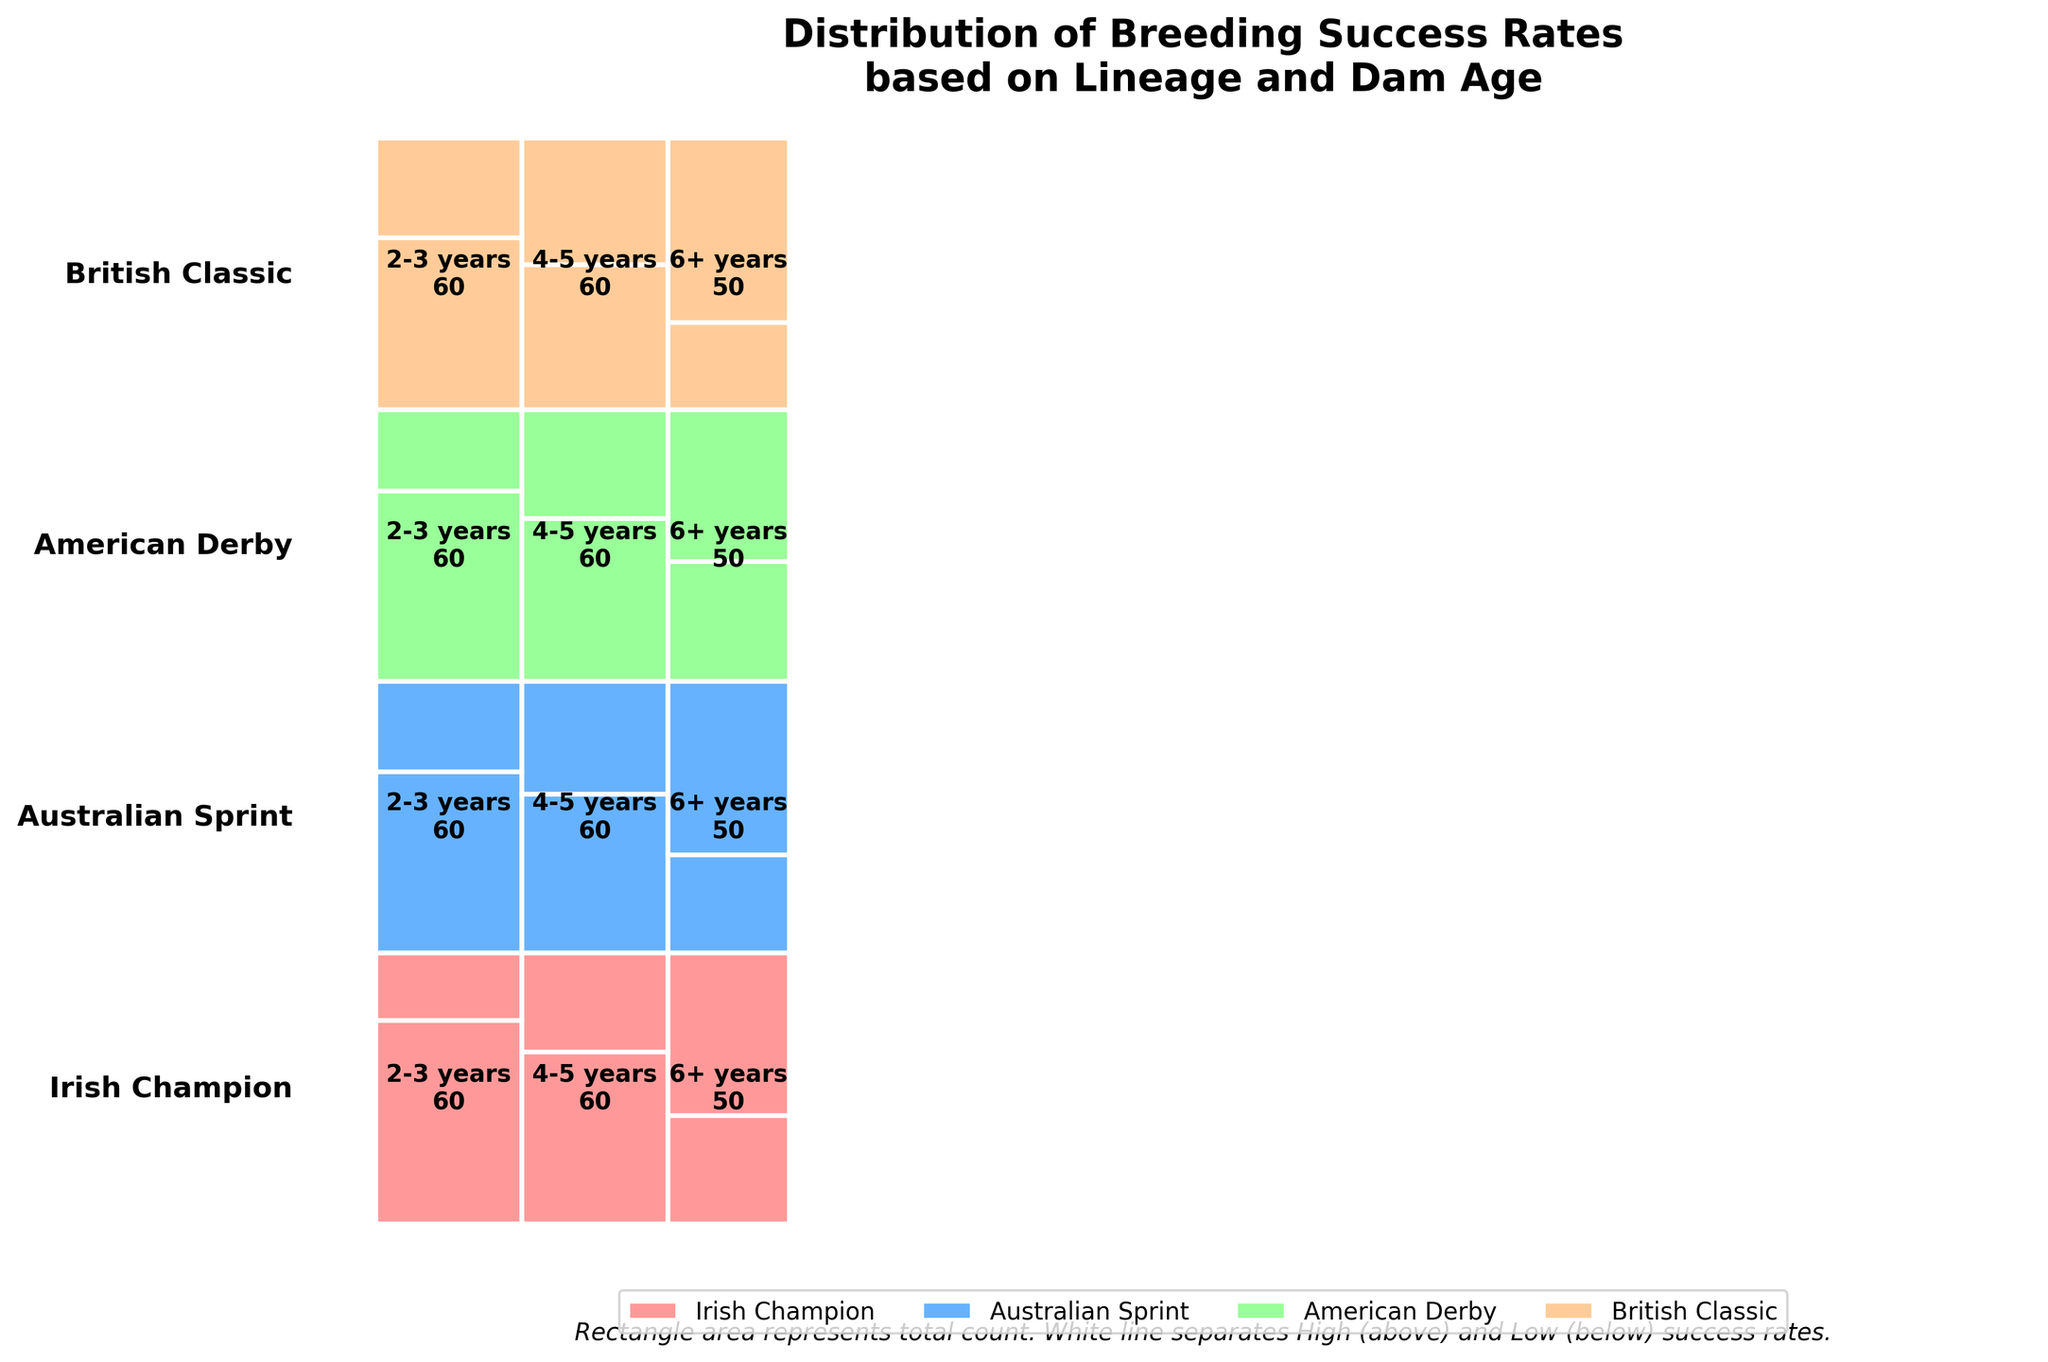Which lineage has the highest total breeding success rate for dams aged 2-3 years? Look at the height of the segments labeled "2-3 years" and how much of it is taken up by the high success section (above the white line). The sum of the count for the high success rate within each lineage can be compared visually. The Irish Champion has a large high-success segment for 2-3 years.
Answer: Irish Champion Which dam age group in the British Classic lineage had the lowest high breeding success rate? Check which segment in the British Classic lineage has the smallest high-success section (portion above the white line). The "6+ years" dam age group has the smallest high-success section.
Answer: 6+ years How does the high breeding success rate for American Derby dams aged 4-5 years compare to that of Australian Sprint dams aged 6+ years? The height of the high success rate in the "4-5 years" section of American Derby lineage is larger than the high success section for the "6+ years" section of the Australian Sprint lineage. This comparison shows a higher breed success in the American Derby 4-5 years group.
Answer: American Derby 4-5 years is higher Which lineage shows a tendency toward higher low breeding success in older dams? Observe the segments of the lineages with older dam ages ("6+ years") and see which one has a larger area dedicated to low success (below the white line). The British Classic shows a tendency for higher low breeding success in older dams.
Answer: British Classic What is the largest overall dam age group observed in the plot? Sum up the width of the segments for each age group across all lineages. The group with the widest total segment indicates the largest dam age group. The "2-3 years" group takes up the most space across the plot.
Answer: 2-3 years Which lineage has the least variance in breeding success rates across all dam ages? Check each lineage and visually assess which one has the most balanced heights between high and low success across all ages. The Australian Sprint seems to have a more balanced high-low success ratio across all dam ages.
Answer: Australian Sprint What is the ratio of high to low breeding success for 4-5 year-old dams in the Irish Champion lineage? Refer to the "4-5 years" segment of the Irish Champion section. High success ratio (38) and low success (22); the ratio is 38:22 which can be simplified further as approximately 1.73:1.
Answer: 1.73:1 What’s the total count of breeding success attempts for the American Derby lineage? Sum the counts of high and low breeding success across all dam age groups in the American Derby lineage. The counts are 42 (2-3 years High) + 18 (2-3 years Low) + 36 (4-5 years High) + 24 (4-5 years Low) + 22 (6+ years High) + 28 (6+ years Low); total is 170.
Answer: 170 